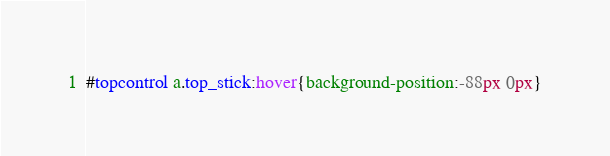Convert code to text. <code><loc_0><loc_0><loc_500><loc_500><_CSS_>#topcontrol a.top_stick:hover{background-position:-88px 0px}</code> 